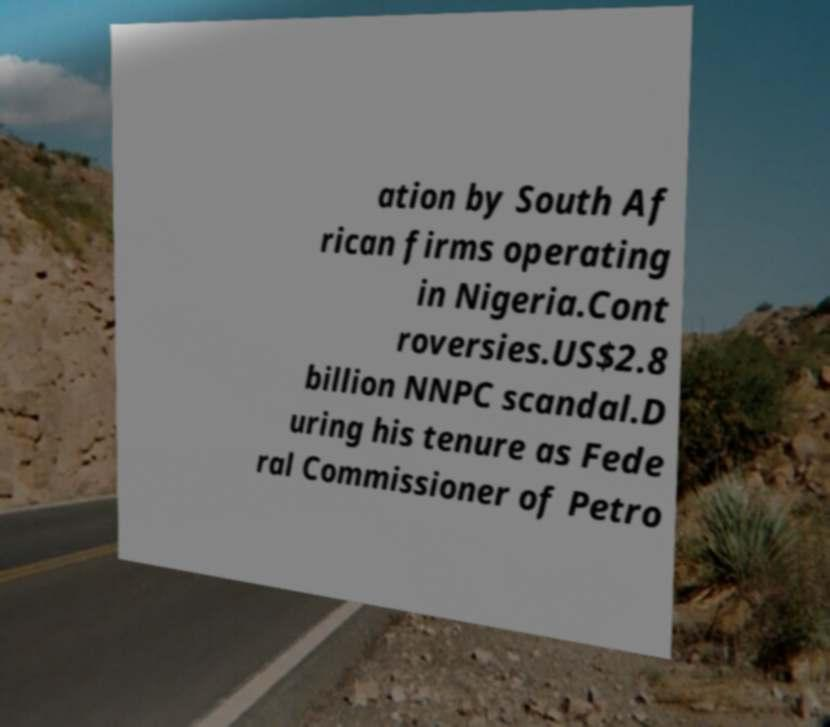Could you assist in decoding the text presented in this image and type it out clearly? ation by South Af rican firms operating in Nigeria.Cont roversies.US$2.8 billion NNPC scandal.D uring his tenure as Fede ral Commissioner of Petro 